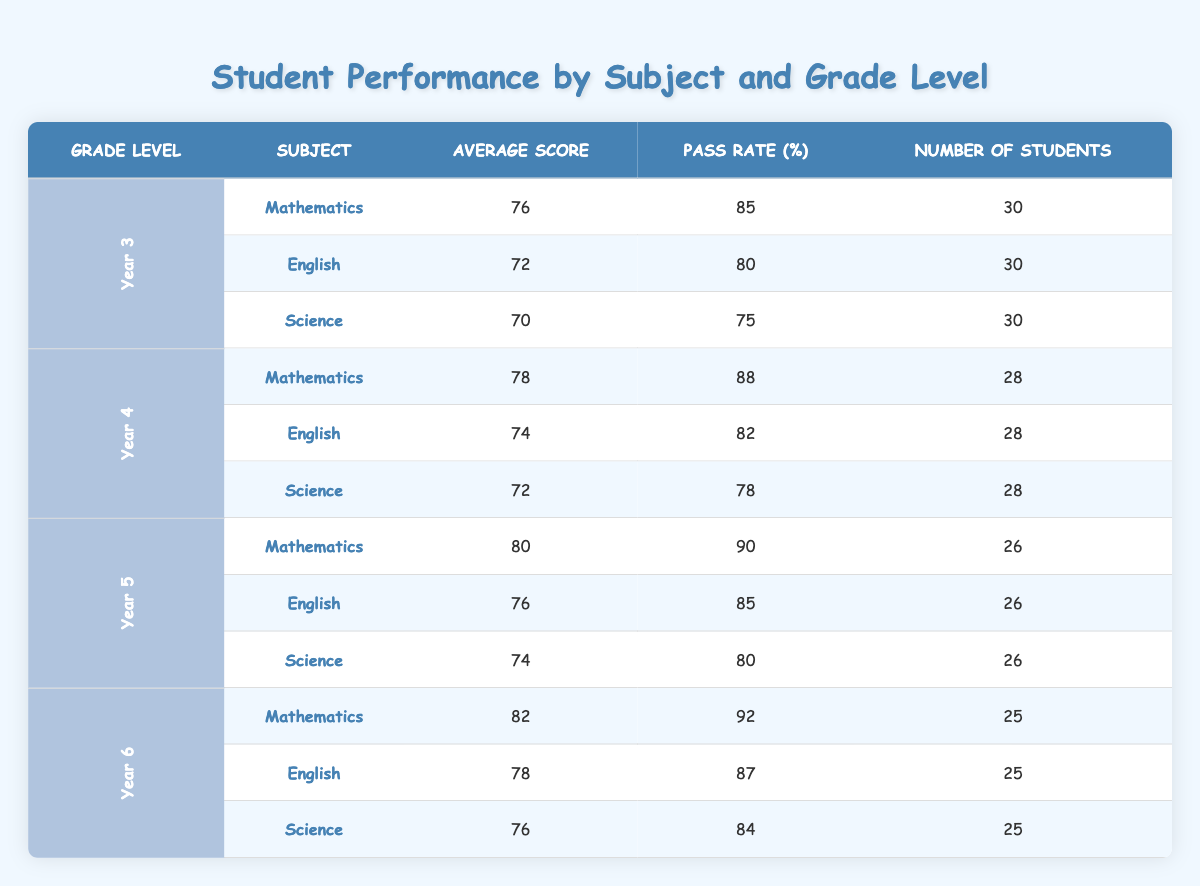What is the average score in Mathematics for Year 5 students? The table shows that the average score in Mathematics for Year 5 students is 80.
Answer: 80 What is the pass rate for English in Year 4? From the table, the pass rate for English in Year 4 is 82%.
Answer: 82 Which subject has the highest average score in Year 6? Looking at Year 6's average scores, Mathematics has the highest average score of 82.
Answer: Mathematics What is the average pass rate across all subjects for Year 3? To find the average pass rate for Year 3, we add the pass rates of all subjects (85 + 80 + 75 = 240) and divide by the number of subjects (3). So, the average pass rate is 240/3 = 80%.
Answer: 80 Do Year 4 students have a higher average score in Mathematics than Year 5 students? Year 4's average score in Mathematics is 78, while Year 5's is 80. Since 80 is greater than 78, the answer is no.
Answer: No What is the total number of students across all subjects in Year 6? Adding up the number of students in Year 6 for all subjects gives us 25 + 25 + 25 = 75.
Answer: 75 Which grade level has the lowest average score in Science? By comparing the average scores for Science across all grade levels, Year 3 has the lowest at 70.
Answer: Year 3 What is the difference in average scores between Year 5 Mathematics and Year 6 English? The average score for Year 5 Mathematics is 80, and for Year 6 English, it is 78. The difference is 80 - 78 = 2.
Answer: 2 What percentage of Year 4 students passed Science? The pass rate for Science in Year 4 is 78%, so this answers the question directly.
Answer: 78 